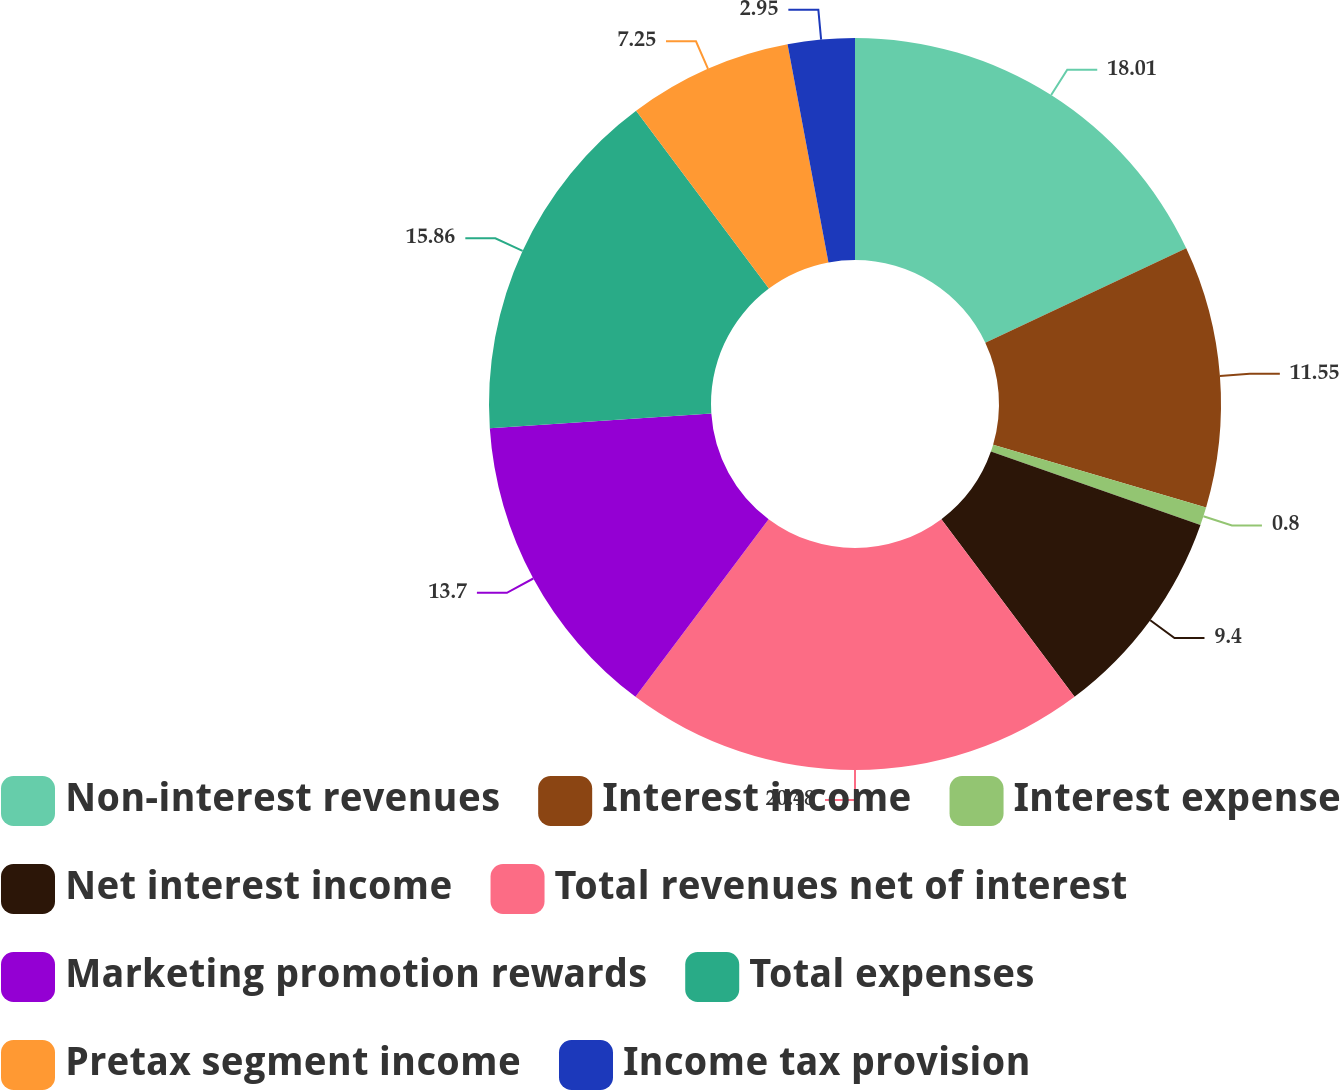<chart> <loc_0><loc_0><loc_500><loc_500><pie_chart><fcel>Non-interest revenues<fcel>Interest income<fcel>Interest expense<fcel>Net interest income<fcel>Total revenues net of interest<fcel>Marketing promotion rewards<fcel>Total expenses<fcel>Pretax segment income<fcel>Income tax provision<nl><fcel>18.0%<fcel>11.55%<fcel>0.8%<fcel>9.4%<fcel>20.47%<fcel>13.7%<fcel>15.85%<fcel>7.25%<fcel>2.95%<nl></chart> 